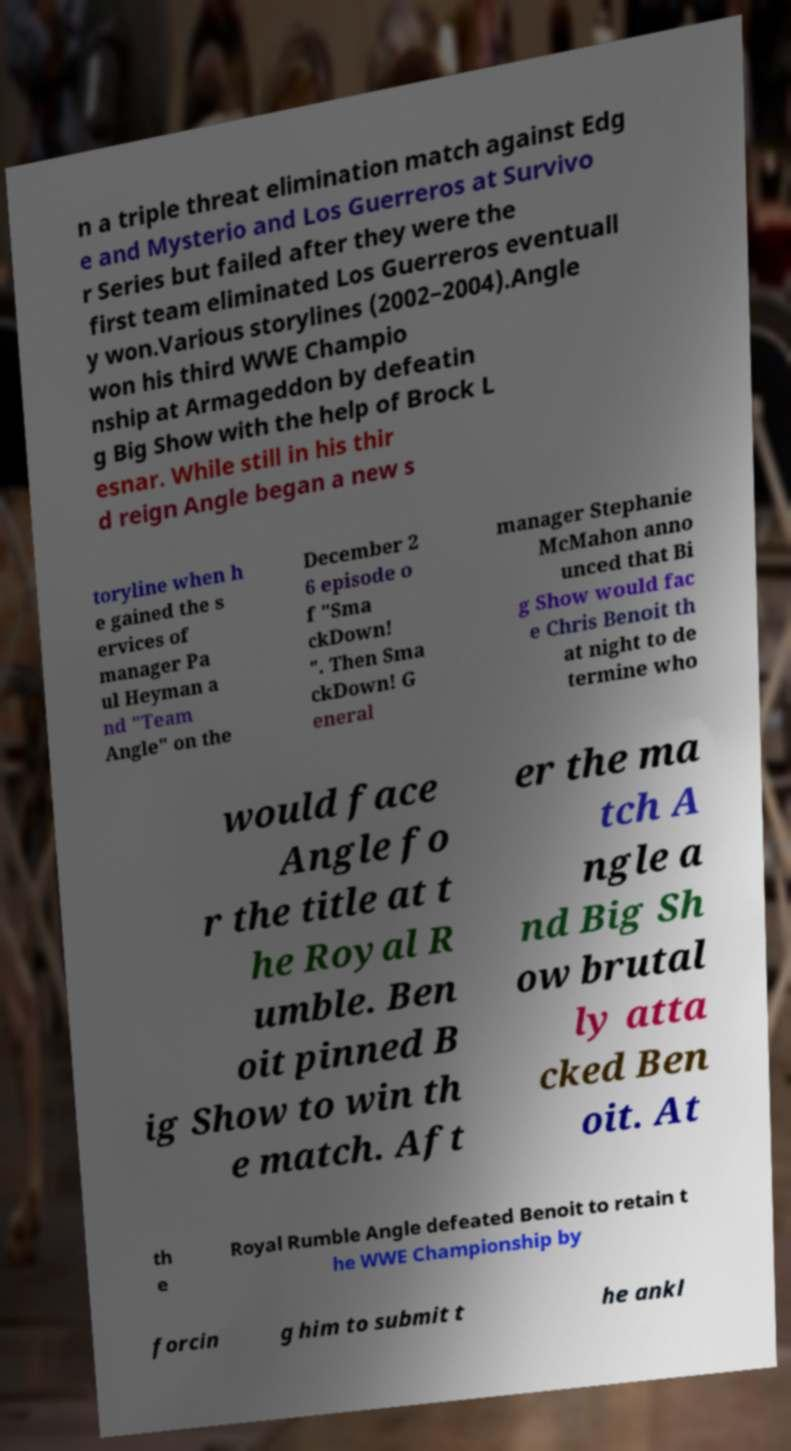For documentation purposes, I need the text within this image transcribed. Could you provide that? n a triple threat elimination match against Edg e and Mysterio and Los Guerreros at Survivo r Series but failed after they were the first team eliminated Los Guerreros eventuall y won.Various storylines (2002–2004).Angle won his third WWE Champio nship at Armageddon by defeatin g Big Show with the help of Brock L esnar. While still in his thir d reign Angle began a new s toryline when h e gained the s ervices of manager Pa ul Heyman a nd "Team Angle" on the December 2 6 episode o f "Sma ckDown! ". Then Sma ckDown! G eneral manager Stephanie McMahon anno unced that Bi g Show would fac e Chris Benoit th at night to de termine who would face Angle fo r the title at t he Royal R umble. Ben oit pinned B ig Show to win th e match. Aft er the ma tch A ngle a nd Big Sh ow brutal ly atta cked Ben oit. At th e Royal Rumble Angle defeated Benoit to retain t he WWE Championship by forcin g him to submit t he ankl 